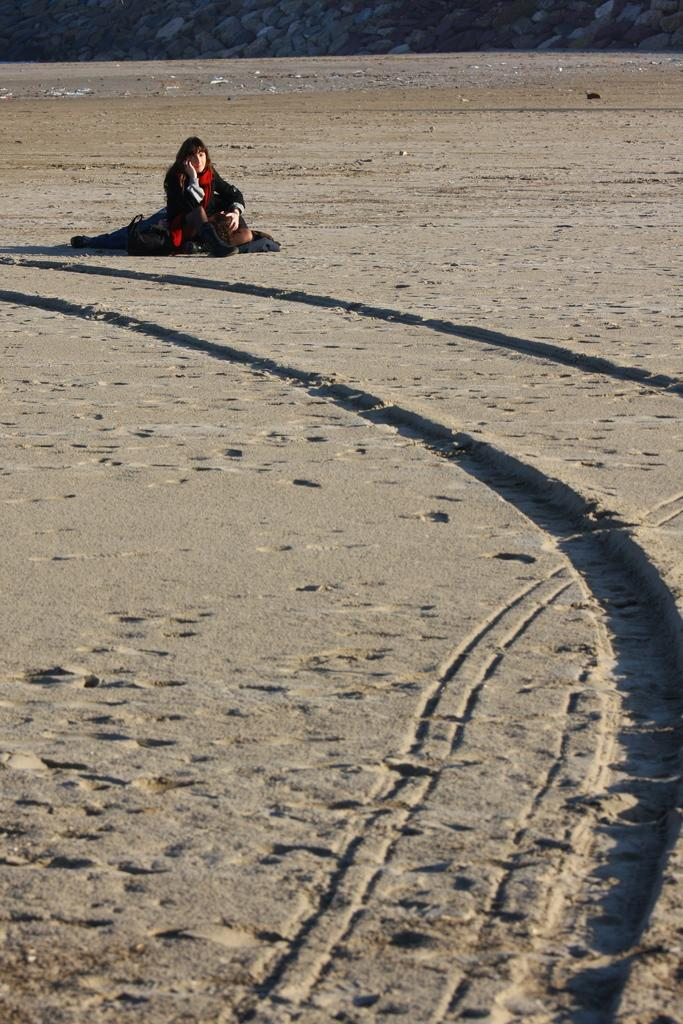Who is present in the image? There is a lady in the image. What is the lady holding in her hand? The lady is holding something in her hand. Where is the lady sitting? The lady is sitting on the sand. What else can be seen near the lady? There is a bag near the lady. What is visible in the background? Rocks are visible on top. What type of current can be seen flowing through the rocks in the image? There is no current visible in the image; it is a still scene with rocks in the background. 